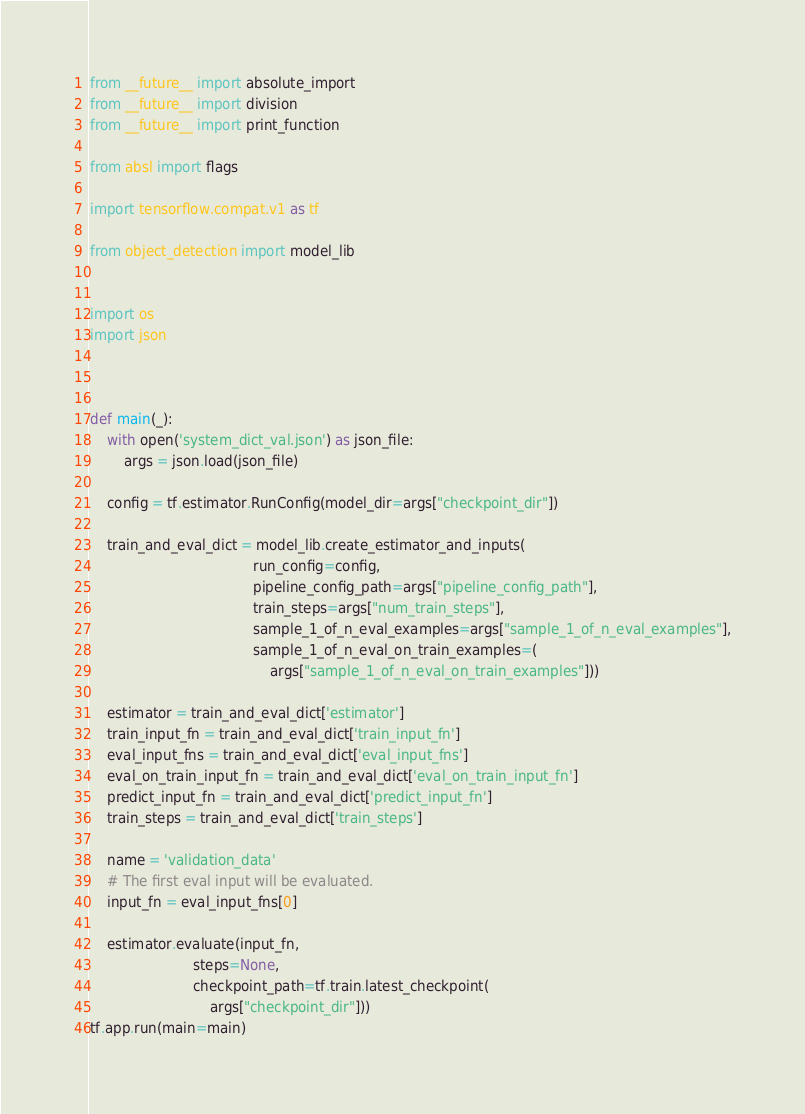Convert code to text. <code><loc_0><loc_0><loc_500><loc_500><_Python_>from __future__ import absolute_import
from __future__ import division
from __future__ import print_function

from absl import flags

import tensorflow.compat.v1 as tf

from object_detection import model_lib


import os
import json



def main(_):
    with open('system_dict_val.json') as json_file:
        args = json.load(json_file) 

    config = tf.estimator.RunConfig(model_dir=args["checkpoint_dir"])
    
    train_and_eval_dict = model_lib.create_estimator_and_inputs(
                                      run_config=config,
                                      pipeline_config_path=args["pipeline_config_path"],
                                      train_steps=args["num_train_steps"],
                                      sample_1_of_n_eval_examples=args["sample_1_of_n_eval_examples"],
                                      sample_1_of_n_eval_on_train_examples=(
                                          args["sample_1_of_n_eval_on_train_examples"]))
    
    estimator = train_and_eval_dict['estimator']
    train_input_fn = train_and_eval_dict['train_input_fn']
    eval_input_fns = train_and_eval_dict['eval_input_fns']
    eval_on_train_input_fn = train_and_eval_dict['eval_on_train_input_fn']
    predict_input_fn = train_and_eval_dict['predict_input_fn']
    train_steps = train_and_eval_dict['train_steps']
    
    name = 'validation_data'
    # The first eval input will be evaluated.
    input_fn = eval_input_fns[0]
        
    estimator.evaluate(input_fn,
                        steps=None,
                        checkpoint_path=tf.train.latest_checkpoint(
                            args["checkpoint_dir"]))
tf.app.run(main=main)</code> 